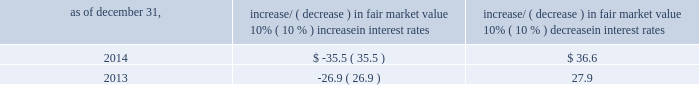Item 7a .
Quantitative and qualitative disclosures about market risk ( amounts in millions ) in the normal course of business , we are exposed to market risks related to interest rates , foreign currency rates and certain balance sheet items .
From time to time , we use derivative instruments , pursuant to established guidelines and policies , to manage some portion of these risks .
Derivative instruments utilized in our hedging activities are viewed as risk management tools and are not used for trading or speculative purposes .
Interest rates our exposure to market risk for changes in interest rates relates primarily to the fair market value and cash flows of our debt obligations .
The majority of our debt ( approximately 91% ( 91 % ) and 86% ( 86 % ) as of december 31 , 2014 and 2013 , respectively ) bears interest at fixed rates .
We do have debt with variable interest rates , but a 10% ( 10 % ) increase or decrease in interest rates would not be material to our interest expense or cash flows .
The fair market value of our debt is sensitive to changes in interest rates , and the impact of a 10% ( 10 % ) change in interest rates is summarized below .
Increase/ ( decrease ) in fair market value as of december 31 , 10% ( 10 % ) increase in interest rates 10% ( 10 % ) decrease in interest rates .
We have used interest rate swaps for risk management purposes to manage our exposure to changes in interest rates .
We do not have any interest rate swaps outstanding as of december 31 , 2014 .
We had $ 1667.2 of cash , cash equivalents and marketable securities as of december 31 , 2014 that we generally invest in conservative , short-term bank deposits or securities .
The interest income generated from these investments is subject to both domestic and foreign interest rate movements .
During 2014 and 2013 , we had interest income of $ 27.4 and $ 24.7 , respectively .
Based on our 2014 results , a 100-basis-point increase or decrease in interest rates would affect our interest income by approximately $ 16.7 , assuming that all cash , cash equivalents and marketable securities are impacted in the same manner and balances remain constant from year-end 2014 levels .
Foreign currency rates we are subject to translation and transaction risks related to changes in foreign currency exchange rates .
Since we report revenues and expenses in u.s .
Dollars , changes in exchange rates may either positively or negatively affect our consolidated revenues and expenses ( as expressed in u.s .
Dollars ) from foreign operations .
The primary foreign currencies that impacted our results during 2014 included the argentine peso , australian dollar , brazilian real and british pound sterling .
Based on 2014 exchange rates and operating results , if the u.s .
Dollar were to strengthen or weaken by 10% ( 10 % ) , we currently estimate operating income would decrease or increase approximately 4% ( 4 % ) , assuming that all currencies are impacted in the same manner and our international revenue and expenses remain constant at 2014 levels .
The functional currency of our foreign operations is generally their respective local currency .
Assets and liabilities are translated at the exchange rates in effect at the balance sheet date , and revenues and expenses are translated at the average exchange rates during the period presented .
The resulting translation adjustments are recorded as a component of accumulated other comprehensive loss , net of tax , in the stockholders 2019 equity section of our consolidated balance sheets .
Our foreign subsidiaries generally collect revenues and pay expenses in their functional currency , mitigating transaction risk .
However , certain subsidiaries may enter into transactions in currencies other than their functional currency .
Assets and liabilities denominated in currencies other than the functional currency are susceptible to movements in foreign currency until final settlement .
Currency transaction gains or losses primarily arising from transactions in currencies other than the functional currency are included in office and general expenses .
We have not entered into a material amount of foreign currency forward exchange contracts or other derivative financial instruments to hedge the effects of potential adverse fluctuations in foreign currency exchange rates. .
What is the growth rate of interest income from 2013 to 2014? 
Computations: ((27.4 - 24.7) / 24.7)
Answer: 0.10931. Item 7a .
Quantitative and qualitative disclosures about market risk ( amounts in millions ) in the normal course of business , we are exposed to market risks related to interest rates , foreign currency rates and certain balance sheet items .
From time to time , we use derivative instruments , pursuant to established guidelines and policies , to manage some portion of these risks .
Derivative instruments utilized in our hedging activities are viewed as risk management tools and are not used for trading or speculative purposes .
Interest rates our exposure to market risk for changes in interest rates relates primarily to the fair market value and cash flows of our debt obligations .
The majority of our debt ( approximately 91% ( 91 % ) and 86% ( 86 % ) as of december 31 , 2014 and 2013 , respectively ) bears interest at fixed rates .
We do have debt with variable interest rates , but a 10% ( 10 % ) increase or decrease in interest rates would not be material to our interest expense or cash flows .
The fair market value of our debt is sensitive to changes in interest rates , and the impact of a 10% ( 10 % ) change in interest rates is summarized below .
Increase/ ( decrease ) in fair market value as of december 31 , 10% ( 10 % ) increase in interest rates 10% ( 10 % ) decrease in interest rates .
We have used interest rate swaps for risk management purposes to manage our exposure to changes in interest rates .
We do not have any interest rate swaps outstanding as of december 31 , 2014 .
We had $ 1667.2 of cash , cash equivalents and marketable securities as of december 31 , 2014 that we generally invest in conservative , short-term bank deposits or securities .
The interest income generated from these investments is subject to both domestic and foreign interest rate movements .
During 2014 and 2013 , we had interest income of $ 27.4 and $ 24.7 , respectively .
Based on our 2014 results , a 100-basis-point increase or decrease in interest rates would affect our interest income by approximately $ 16.7 , assuming that all cash , cash equivalents and marketable securities are impacted in the same manner and balances remain constant from year-end 2014 levels .
Foreign currency rates we are subject to translation and transaction risks related to changes in foreign currency exchange rates .
Since we report revenues and expenses in u.s .
Dollars , changes in exchange rates may either positively or negatively affect our consolidated revenues and expenses ( as expressed in u.s .
Dollars ) from foreign operations .
The primary foreign currencies that impacted our results during 2014 included the argentine peso , australian dollar , brazilian real and british pound sterling .
Based on 2014 exchange rates and operating results , if the u.s .
Dollar were to strengthen or weaken by 10% ( 10 % ) , we currently estimate operating income would decrease or increase approximately 4% ( 4 % ) , assuming that all currencies are impacted in the same manner and our international revenue and expenses remain constant at 2014 levels .
The functional currency of our foreign operations is generally their respective local currency .
Assets and liabilities are translated at the exchange rates in effect at the balance sheet date , and revenues and expenses are translated at the average exchange rates during the period presented .
The resulting translation adjustments are recorded as a component of accumulated other comprehensive loss , net of tax , in the stockholders 2019 equity section of our consolidated balance sheets .
Our foreign subsidiaries generally collect revenues and pay expenses in their functional currency , mitigating transaction risk .
However , certain subsidiaries may enter into transactions in currencies other than their functional currency .
Assets and liabilities denominated in currencies other than the functional currency are susceptible to movements in foreign currency until final settlement .
Currency transaction gains or losses primarily arising from transactions in currencies other than the functional currency are included in office and general expenses .
We have not entered into a material amount of foreign currency forward exchange contracts or other derivative financial instruments to hedge the effects of potential adverse fluctuations in foreign currency exchange rates. .
What is the average interest income for 2013 and 2014 , in millions? 
Computations: ((27.4 + 24.7) / 2)
Answer: 26.05. 